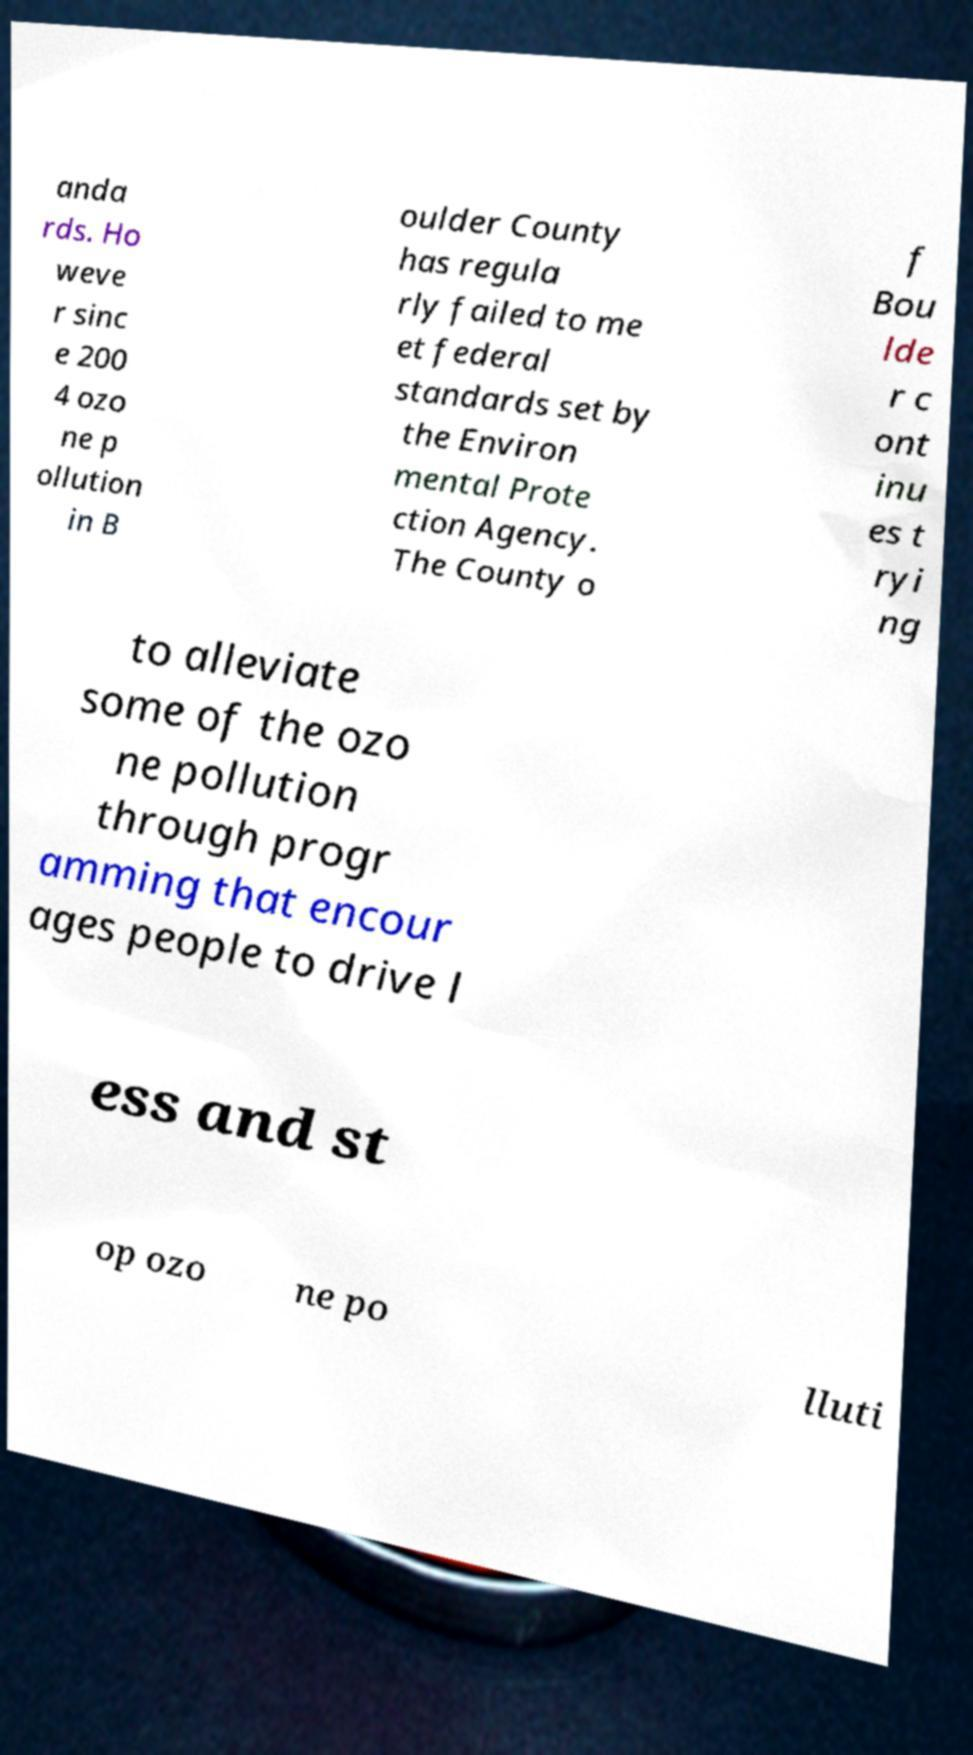Could you extract and type out the text from this image? anda rds. Ho weve r sinc e 200 4 ozo ne p ollution in B oulder County has regula rly failed to me et federal standards set by the Environ mental Prote ction Agency. The County o f Bou lde r c ont inu es t ryi ng to alleviate some of the ozo ne pollution through progr amming that encour ages people to drive l ess and st op ozo ne po lluti 